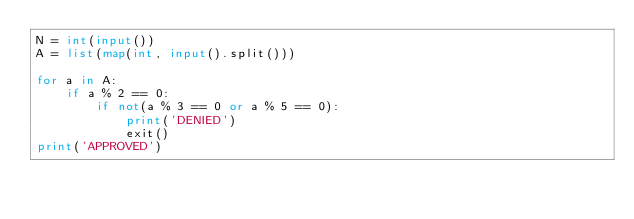Convert code to text. <code><loc_0><loc_0><loc_500><loc_500><_Python_>N = int(input())
A = list(map(int, input().split()))

for a in A:
    if a % 2 == 0:
        if not(a % 3 == 0 or a % 5 == 0):
            print('DENIED')
            exit()
print('APPROVED')
</code> 